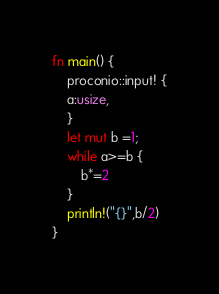Convert code to text. <code><loc_0><loc_0><loc_500><loc_500><_Rust_>fn main() {
    proconio::input! {
    a:usize,
    }
    let mut b =1;
    while a>=b {
        b*=2
    }
    println!("{}",b/2)
}</code> 